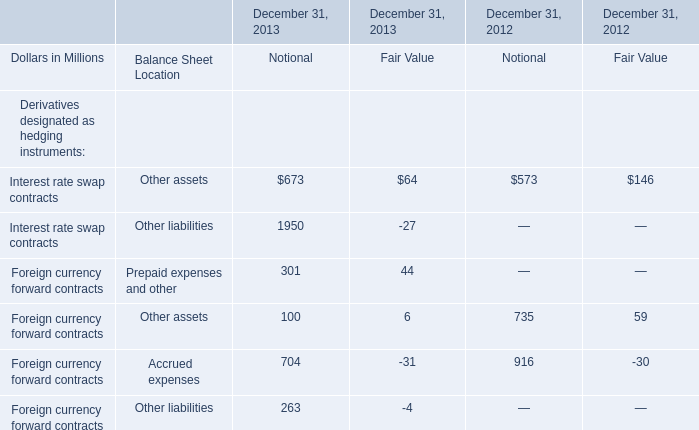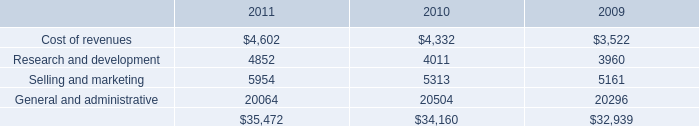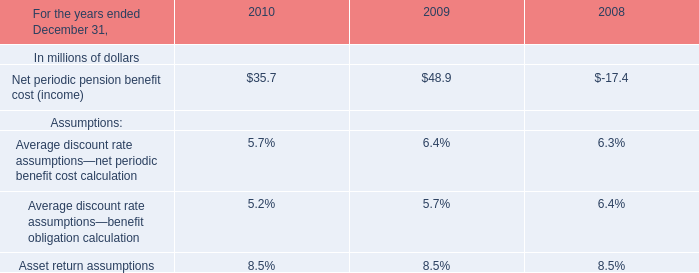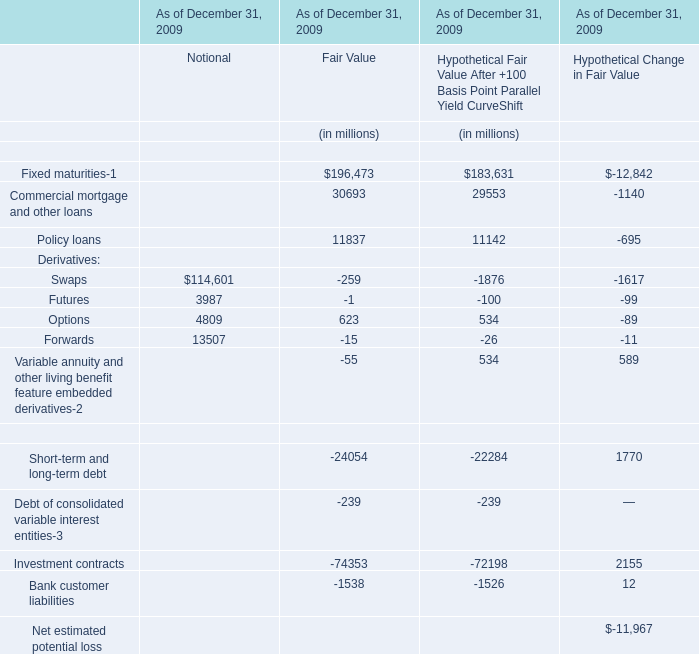What is the sum of elements for Hypothetical Fair Value After +100 Basis Point Parallel Yield CurveShift in the range of 1 and 20000 in 2009? (in million) 
Computations: ((11142 + 534) + 534)
Answer: 12210.0. 